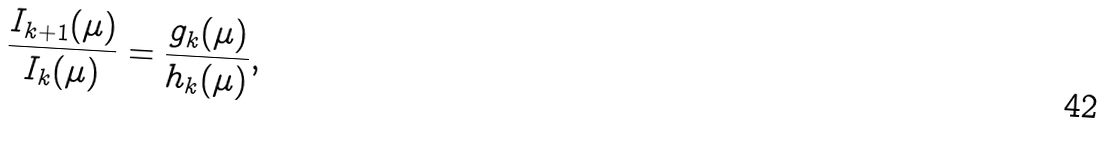<formula> <loc_0><loc_0><loc_500><loc_500>\frac { I _ { k + 1 } ( \mu ) } { I _ { k } ( \mu ) } = \frac { g _ { k } ( \mu ) } { h _ { k } ( \mu ) } ,</formula> 